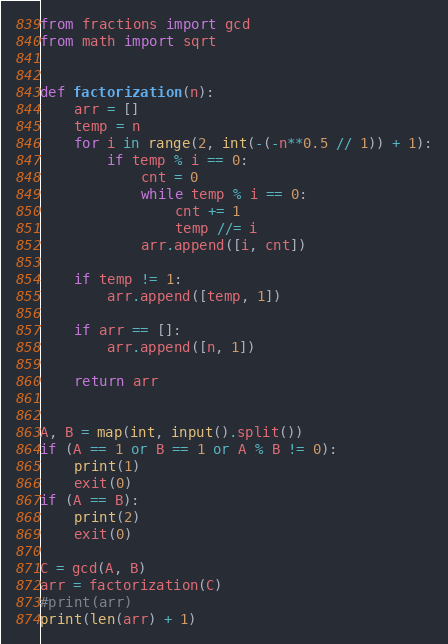Convert code to text. <code><loc_0><loc_0><loc_500><loc_500><_Python_>from fractions import gcd
from math import sqrt


def factorization(n):
    arr = []
    temp = n
    for i in range(2, int(-(-n**0.5 // 1)) + 1):
        if temp % i == 0:
            cnt = 0
            while temp % i == 0:
                cnt += 1
                temp //= i
            arr.append([i, cnt])

    if temp != 1:
        arr.append([temp, 1])

    if arr == []:
        arr.append([n, 1])

    return arr


A, B = map(int, input().split())
if (A == 1 or B == 1 or A % B != 0):
    print(1)
    exit(0)
if (A == B):
    print(2)
    exit(0)

C = gcd(A, B)
arr = factorization(C)
#print(arr)
print(len(arr) + 1)
</code> 